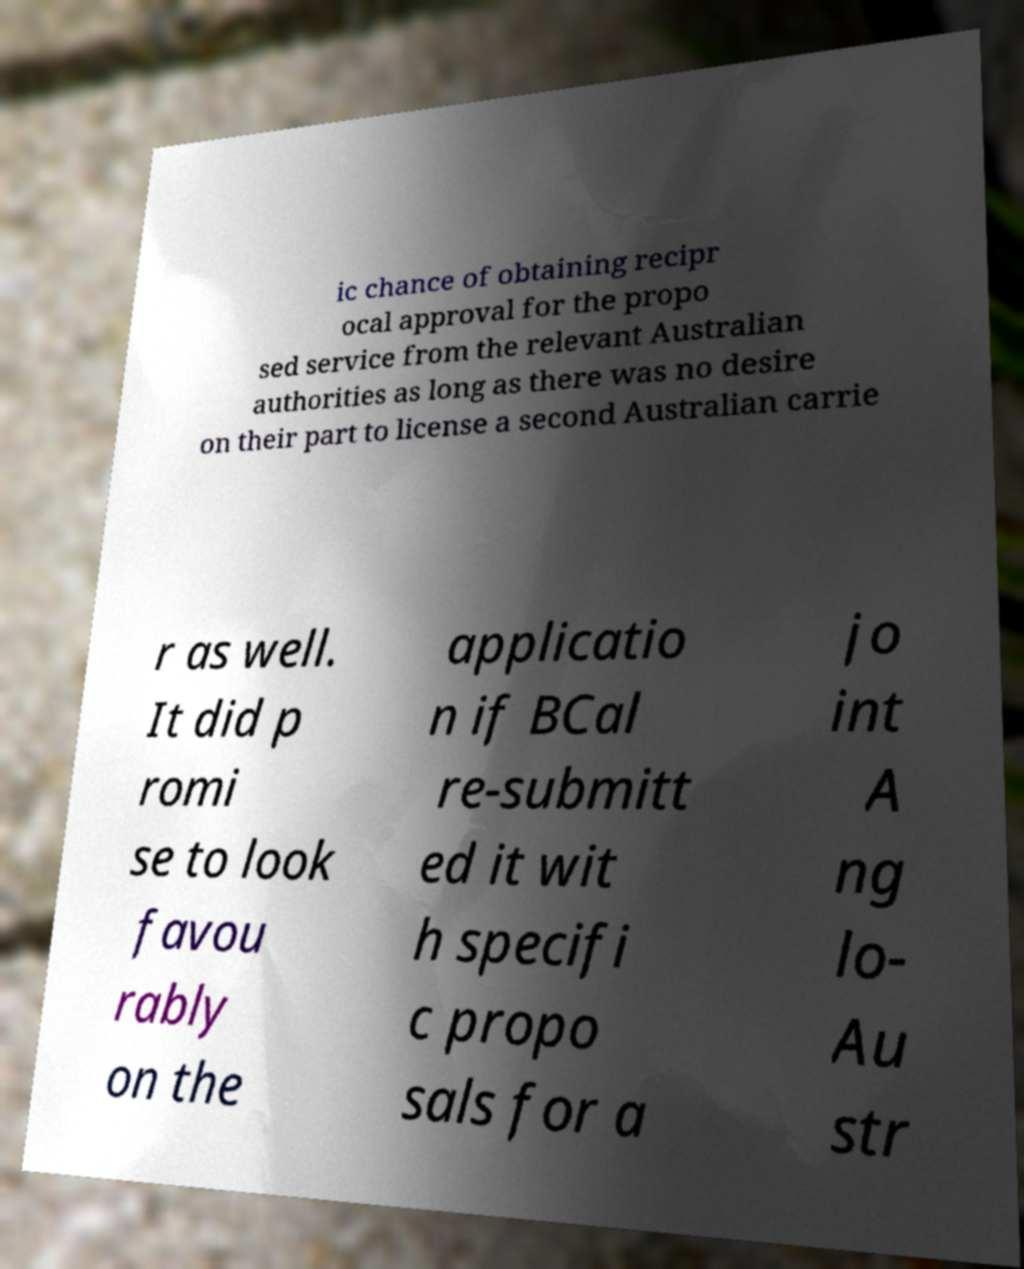There's text embedded in this image that I need extracted. Can you transcribe it verbatim? ic chance of obtaining recipr ocal approval for the propo sed service from the relevant Australian authorities as long as there was no desire on their part to license a second Australian carrie r as well. It did p romi se to look favou rably on the applicatio n if BCal re-submitt ed it wit h specifi c propo sals for a jo int A ng lo- Au str 